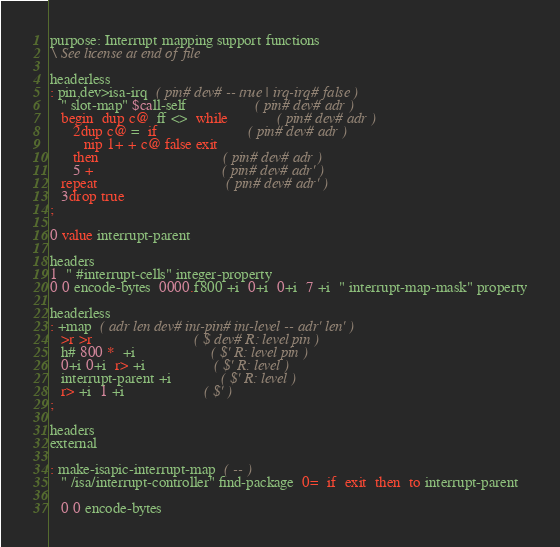<code> <loc_0><loc_0><loc_500><loc_500><_Forth_>purpose: Interrupt mapping support functions
\ See license at end of file

headerless
: pin,dev>isa-irq  ( pin# dev# -- true | irq-irq# false )
   " slot-map" $call-self                  ( pin# dev# adr )
   begin  dup c@  ff <>  while             ( pin# dev# adr )
      2dup c@ =  if                        ( pin# dev# adr )
         nip 1+ + c@ false exit
      then                                 ( pin# dev# adr )
      5 +                                  ( pin# dev# adr' )
   repeat                                  ( pin# dev# adr' )
   3drop true
;

0 value interrupt-parent

headers
1  " #interrupt-cells" integer-property
0 0 encode-bytes  0000.f800 +i  0+i  0+i  7 +i  " interrupt-map-mask" property

headerless
: +map  ( adr len dev# int-pin# int-level -- adr' len' )
   >r >r                           ( $ dev# R: level pin )
   h# 800 *  +i                    ( $' R: level pin )
   0+i 0+i  r> +i                  ( $' R: level )
   interrupt-parent +i             ( $' R: level )
   r> +i  1 +i                     ( $' )
;

headers
external

: make-isapic-interrupt-map  ( -- )
   " /isa/interrupt-controller" find-package  0=  if  exit  then  to interrupt-parent

   0 0 encode-bytes
</code> 